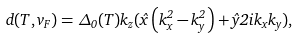<formula> <loc_0><loc_0><loc_500><loc_500>d ( T , v _ { F } ) = \Delta _ { 0 } ( T ) k _ { z } ( \hat { x } \left ( k _ { x } ^ { 2 } - k _ { y } ^ { 2 } \right ) + \hat { y } 2 i k _ { x } k _ { y } ) ,</formula> 